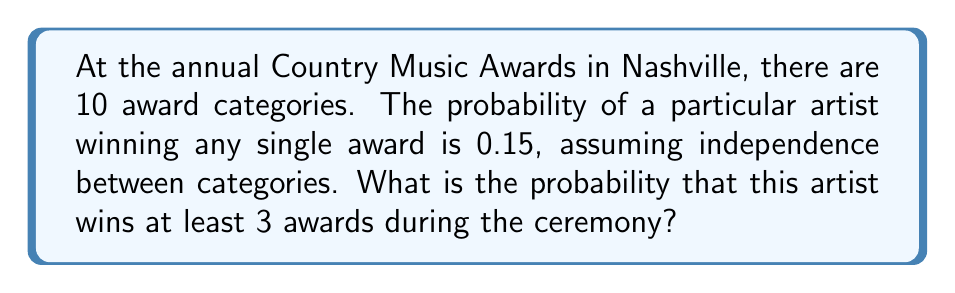Can you solve this math problem? Let's approach this step-by-step using the binomial probability distribution:

1) We can model this scenario as a binomial experiment with:
   $n = 10$ (number of trials/categories)
   $p = 0.15$ (probability of success in each trial)
   $X =$ number of awards won

2) We want to find $P(X \geq 3)$

3) It's easier to calculate $P(X \geq 3) = 1 - P(X < 3) = 1 - P(X \leq 2)$

4) Using the binomial probability formula:
   $$P(X = k) = \binom{n}{k} p^k (1-p)^{n-k}$$

5) We need to sum this for $k = 0, 1, 2$:
   $$P(X \leq 2) = \binom{10}{0} (0.15)^0 (0.85)^{10} + \binom{10}{1} (0.15)^1 (0.85)^9 + \binom{10}{2} (0.15)^2 (0.85)^8$$

6) Calculating each term:
   $\binom{10}{0} (0.15)^0 (0.85)^{10} = 1 \cdot 1 \cdot 0.1969 = 0.1969$
   $\binom{10}{1} (0.15)^1 (0.85)^9 = 10 \cdot 0.15 \cdot 0.2316 = 0.3474$
   $\binom{10}{2} (0.15)^2 (0.85)^8 = 45 \cdot 0.0225 \cdot 0.2725 = 0.2758$

7) Summing these: $P(X \leq 2) = 0.1969 + 0.3474 + 0.2758 = 0.8201$

8) Therefore, $P(X \geq 3) = 1 - 0.8201 = 0.1799$
Answer: 0.1799 